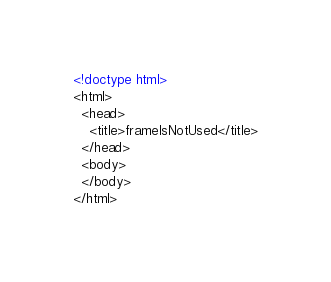<code> <loc_0><loc_0><loc_500><loc_500><_HTML_><!doctype html>
<html>
  <head>
    <title>frameIsNotUsed</title>
  </head>
  <body>
  </body>
</html>
</code> 